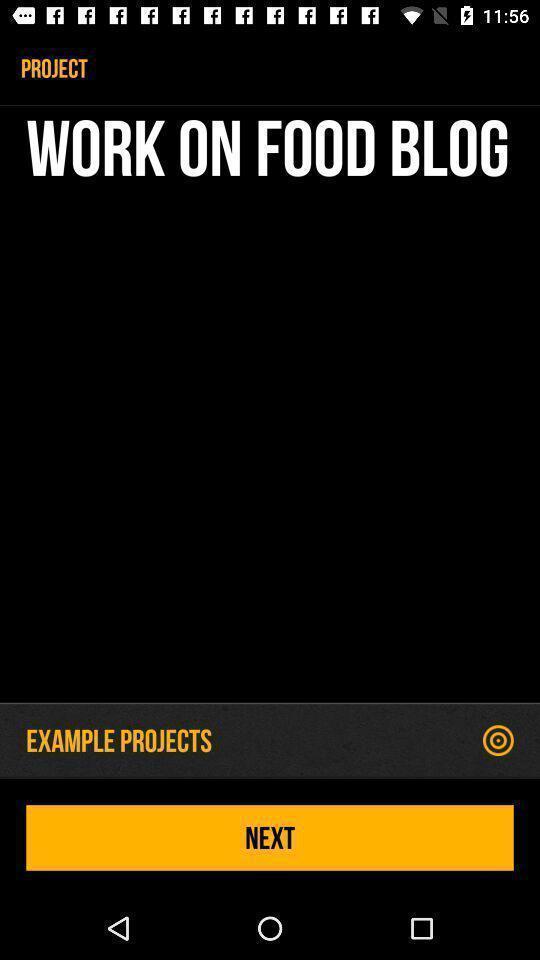Give me a narrative description of this picture. Screen showing work on food blog with next option. 